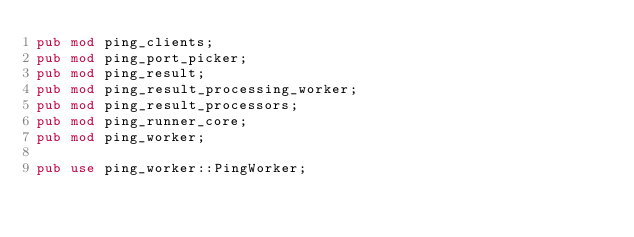<code> <loc_0><loc_0><loc_500><loc_500><_Rust_>pub mod ping_clients;
pub mod ping_port_picker;
pub mod ping_result;
pub mod ping_result_processing_worker;
pub mod ping_result_processors;
pub mod ping_runner_core;
pub mod ping_worker;

pub use ping_worker::PingWorker;
</code> 